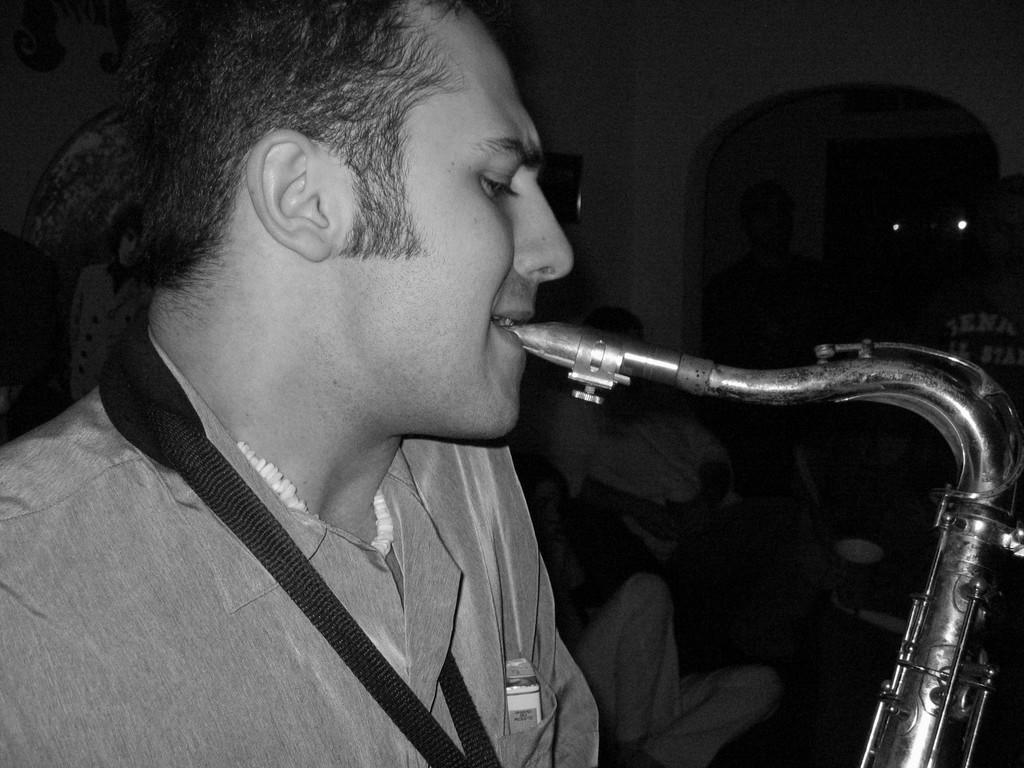What is the color scheme of the image? The image is black and white. What is the man in the image doing? The man is playing a musical instrument with his mouth. What can be seen in the background of the image? There are people, a wall, lights, and objects in the background of the image. How many spiders are crawling on the wall in the image? There are no spiders visible in the image; it only shows a man playing a musical instrument and the background elements. What type of pest is present in the image? There is no pest present in the image. 